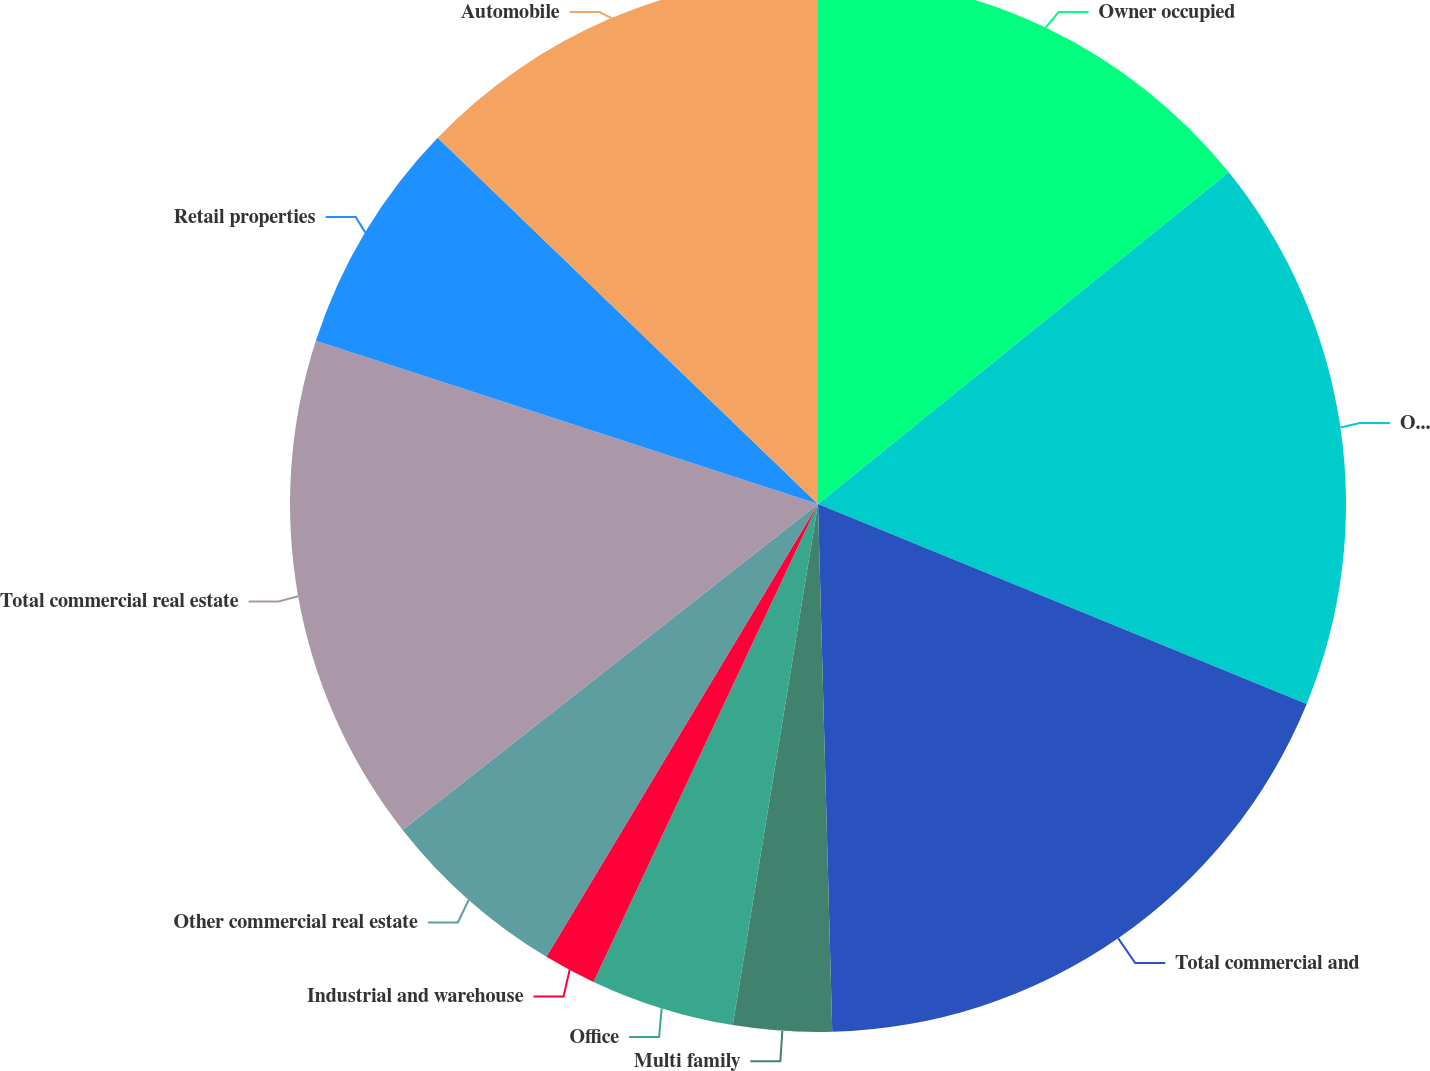Convert chart to OTSL. <chart><loc_0><loc_0><loc_500><loc_500><pie_chart><fcel>Owner occupied<fcel>Other commercial and<fcel>Total commercial and<fcel>Multi family<fcel>Office<fcel>Industrial and warehouse<fcel>Other commercial real estate<fcel>Total commercial real estate<fcel>Retail properties<fcel>Automobile<nl><fcel>14.19%<fcel>16.99%<fcel>18.39%<fcel>3.01%<fcel>4.41%<fcel>1.61%<fcel>5.81%<fcel>15.59%<fcel>7.2%<fcel>12.8%<nl></chart> 